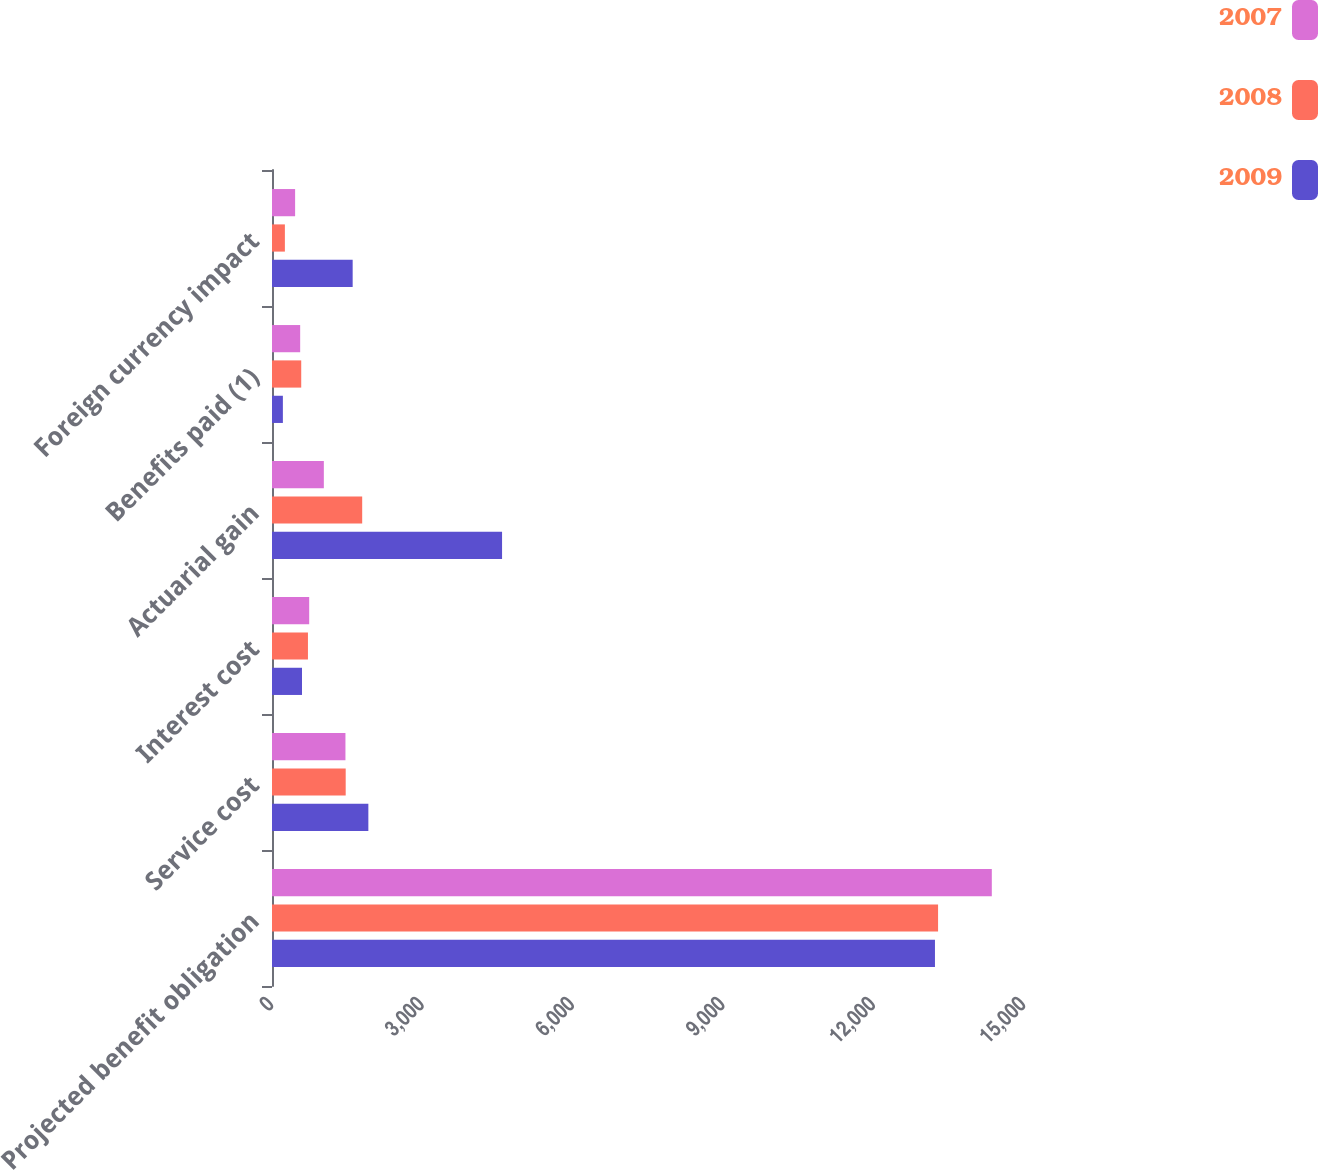Convert chart to OTSL. <chart><loc_0><loc_0><loc_500><loc_500><stacked_bar_chart><ecel><fcel>Projected benefit obligation<fcel>Service cost<fcel>Interest cost<fcel>Actuarial gain<fcel>Benefits paid (1)<fcel>Foreign currency impact<nl><fcel>2007<fcel>14358<fcel>1465<fcel>742<fcel>1034<fcel>562<fcel>461<nl><fcel>2008<fcel>13286<fcel>1470<fcel>717<fcel>1799<fcel>583<fcel>257<nl><fcel>2009<fcel>13224<fcel>1922<fcel>599<fcel>4589<fcel>217<fcel>1609<nl></chart> 